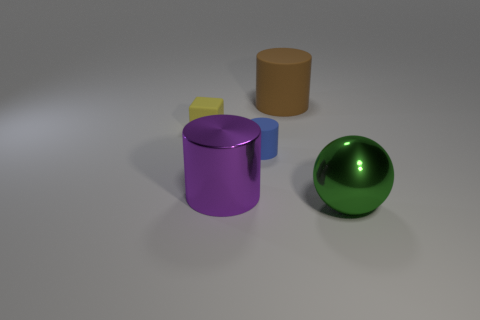Add 5 large cyan things. How many objects exist? 10 Subtract all balls. How many objects are left? 4 Subtract all brown matte cylinders. Subtract all large brown rubber objects. How many objects are left? 3 Add 1 large shiny cylinders. How many large shiny cylinders are left? 2 Add 4 purple cylinders. How many purple cylinders exist? 5 Subtract 0 gray cylinders. How many objects are left? 5 